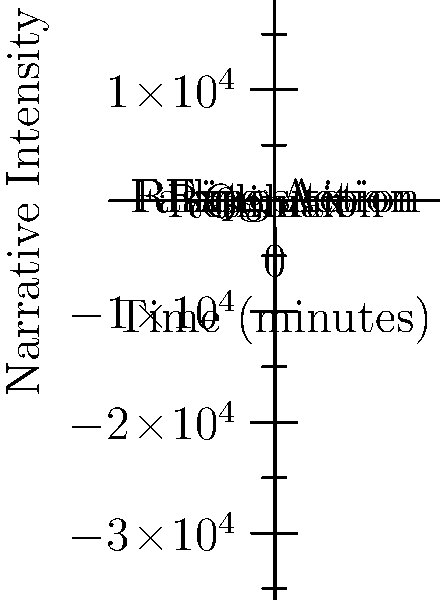The polynomial graph above represents the narrative arc of a classic film. Identify the point on the graph that corresponds to the climax of the film and explain its significance in terms of narrative structure. To answer this question, let's analyze the graph step-by-step:

1. The x-axis represents time in minutes, while the y-axis represents narrative intensity.

2. The graph shows a polynomial curve that rises, peaks, and then falls.

3. In narrative structure, the climax is typically the point of highest tension or conflict in the story.

4. On this graph, the climax would correspond to the highest point of the curve.

5. We can see that the curve reaches its peak at approximately (70, 4.5) on the graph.

6. This point is also labeled "Climax" on the graph, confirming our interpretation.

7. The significance of the climax in narrative structure:
   a) It represents the turning point of the story.
   b) It's usually the most intense or dramatic moment.
   c) It often resolves the main conflict or reveals a crucial truth.
   d) After the climax, the tension begins to decrease (falling action).

8. We can see this structure reflected in the graph:
   - The curve rises (rising action) leading up to the climax.
   - After the peak, the curve descends (falling action).
   - The curve ends at a lower point than the climax (resolution).

This polynomial model effectively visualizes the pacing and intensity of the film's narrative, with the climax as its central, pivotal point.
Answer: The climax occurs at approximately (70, 4.5), representing the peak of narrative intensity and the story's turning point. 